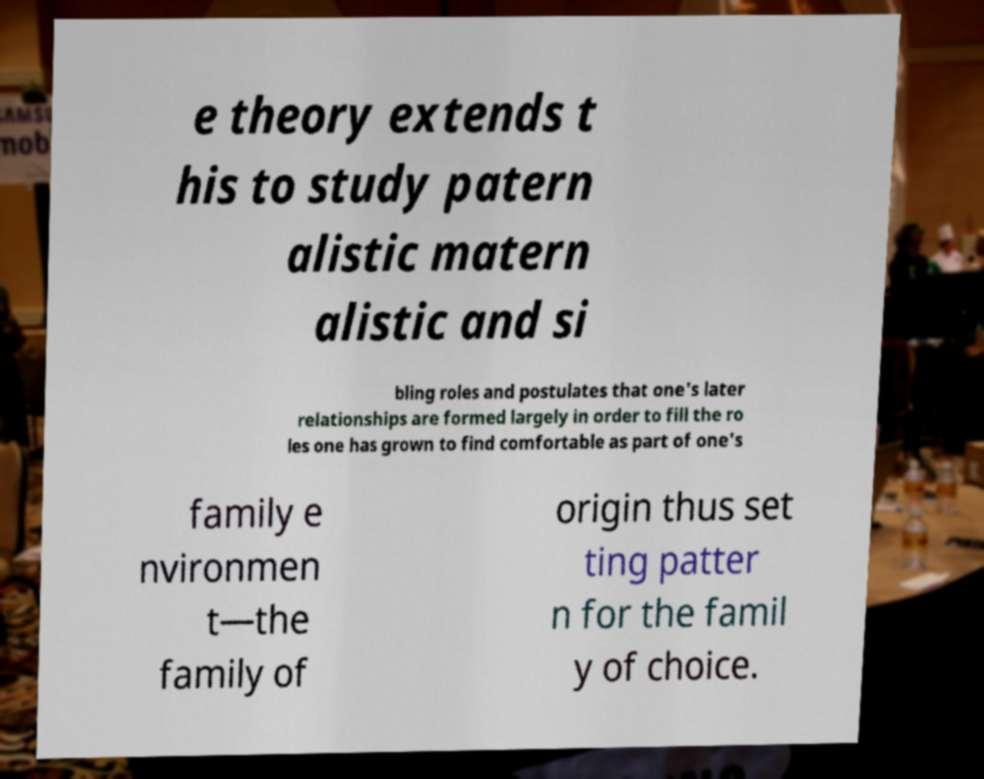Please read and relay the text visible in this image. What does it say? e theory extends t his to study patern alistic matern alistic and si bling roles and postulates that one's later relationships are formed largely in order to fill the ro les one has grown to find comfortable as part of one's family e nvironmen t—the family of origin thus set ting patter n for the famil y of choice. 